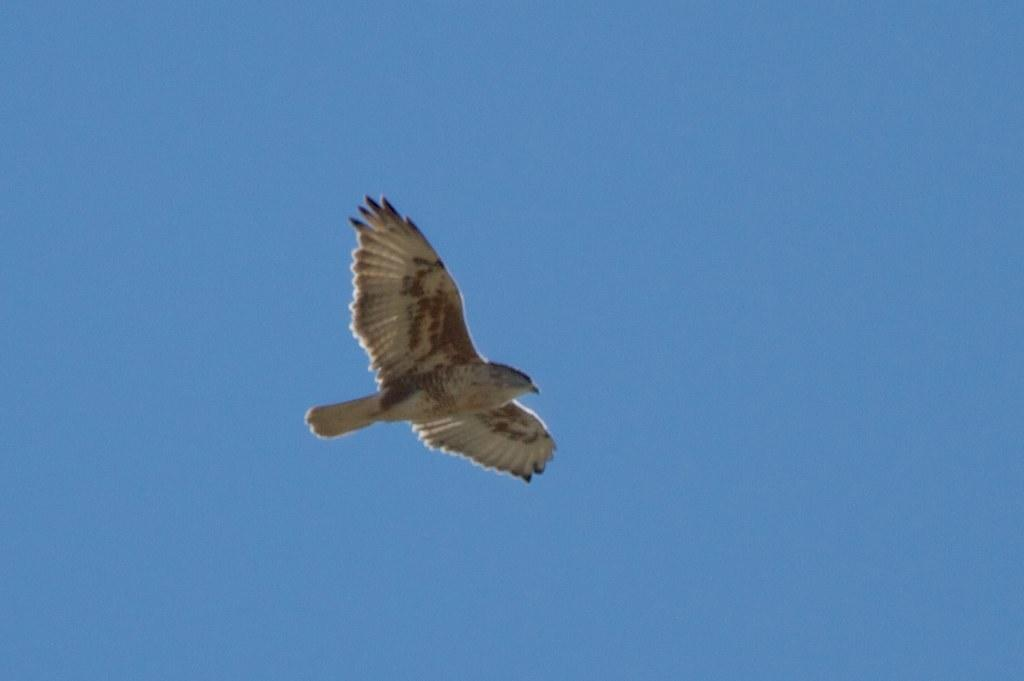What type of animal can be seen in the image? There is a bird in the image. What color is the bird? The bird is yellow in color. What is visible in the background of the image? There is sky visible in the image. Are there any dinosaurs visible in the image? No, there are no dinosaurs present in the image. Is the bird wearing a collar in the image? No, the bird is not wearing a collar in the image. 